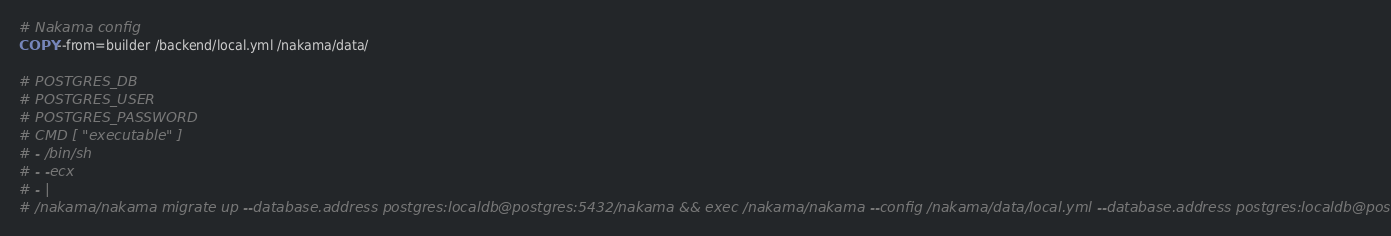<code> <loc_0><loc_0><loc_500><loc_500><_Dockerfile_># Nakama config
COPY --from=builder /backend/local.yml /nakama/data/

# POSTGRES_DB
# POSTGRES_USER
# POSTGRES_PASSWORD
# CMD [ "executable" ]
# - /bin/sh
# - -ecx
# - |
# /nakama/nakama migrate up --database.address postgres:localdb@postgres:5432/nakama && exec /nakama/nakama --config /nakama/data/local.yml --database.address postgres:localdb@postgres:5432/nakama</code> 